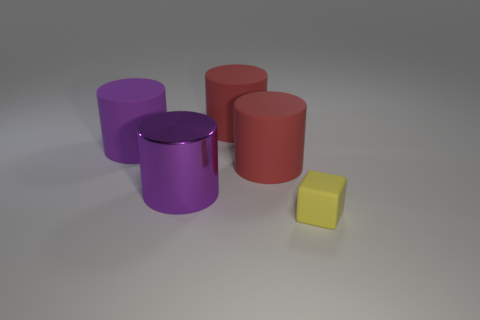Do the rubber cylinder behind the purple matte object and the big rubber cylinder that is in front of the big purple matte object have the same color?
Your answer should be very brief. Yes. There is a purple thing that is behind the metallic cylinder; what number of yellow rubber things are on the left side of it?
Your answer should be compact. 0. There is a purple cylinder that is the same size as the purple shiny thing; what is it made of?
Your answer should be very brief. Rubber. How many other things are there of the same material as the tiny thing?
Provide a short and direct response. 3. There is a small block; what number of things are behind it?
Offer a very short reply. 4. What number of cylinders are yellow matte things or large purple matte objects?
Your answer should be very brief. 1. How many other things are the same color as the matte cube?
Your answer should be compact. 0. Is the material of the yellow thing the same as the large thing that is on the left side of the metal cylinder?
Your answer should be compact. Yes. How many objects are things to the left of the matte block or big cubes?
Provide a short and direct response. 4. Is there any other thing that is the same size as the yellow thing?
Make the answer very short. No. 